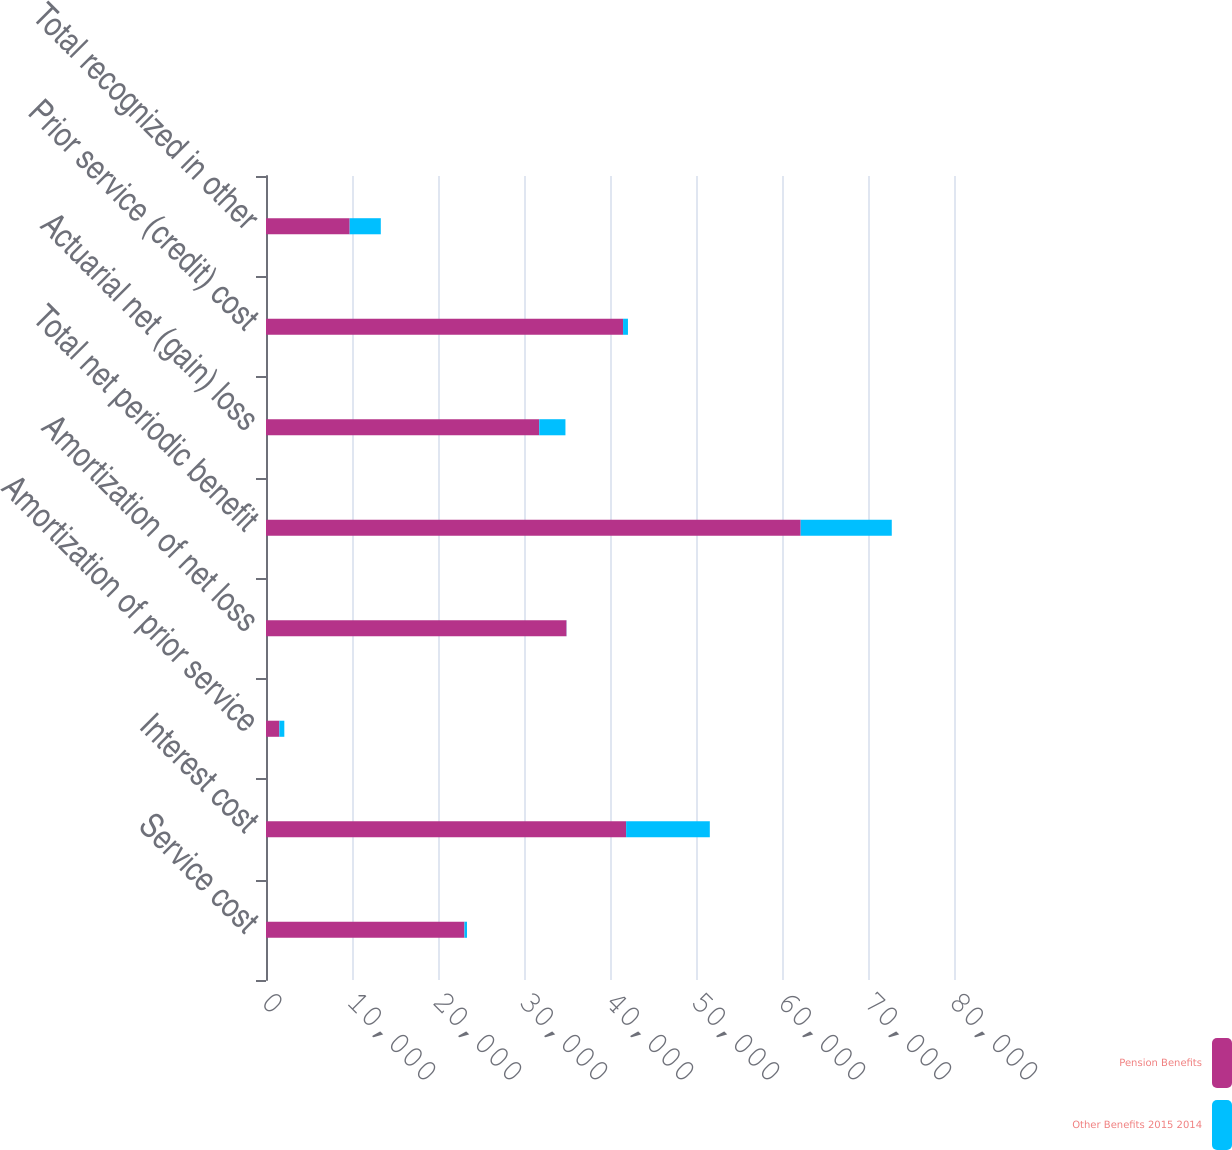Convert chart. <chart><loc_0><loc_0><loc_500><loc_500><stacked_bar_chart><ecel><fcel>Service cost<fcel>Interest cost<fcel>Amortization of prior service<fcel>Amortization of net loss<fcel>Total net periodic benefit<fcel>Actuarial net (gain) loss<fcel>Prior service (credit) cost<fcel>Total recognized in other<nl><fcel>Pension Benefits<fcel>23075<fcel>41875<fcel>1555<fcel>34940<fcel>62172<fcel>31772<fcel>41517<fcel>9731<nl><fcel>Other Benefits 2015 2014<fcel>299<fcel>9731<fcel>575<fcel>13<fcel>10592<fcel>3047<fcel>572<fcel>3619<nl></chart> 